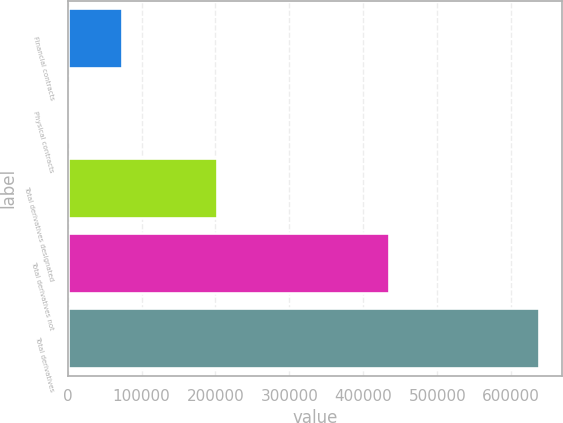Convert chart. <chart><loc_0><loc_0><loc_500><loc_500><bar_chart><fcel>Financial contracts<fcel>Physical contracts<fcel>Total derivatives designated<fcel>Total derivatives not<fcel>Total derivatives<nl><fcel>73346<fcel>344<fcel>202356<fcel>434885<fcel>637241<nl></chart> 